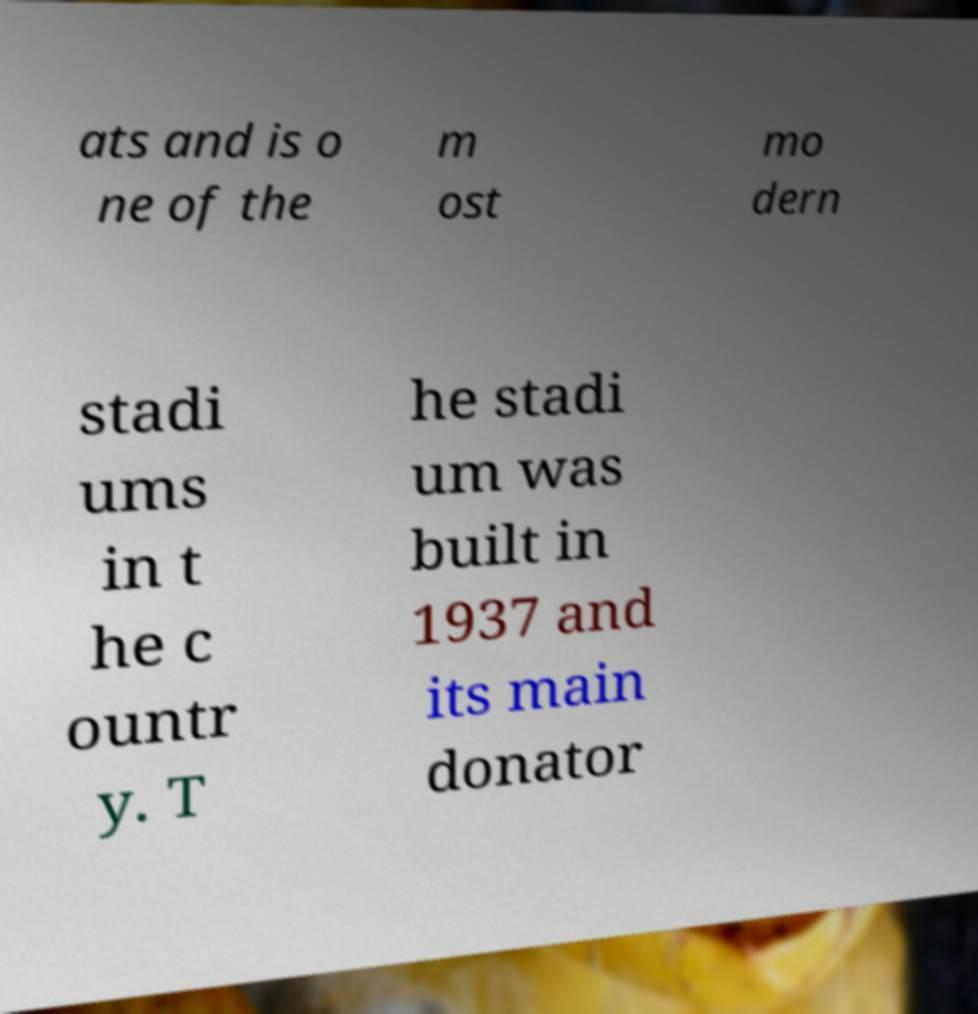What messages or text are displayed in this image? I need them in a readable, typed format. ats and is o ne of the m ost mo dern stadi ums in t he c ountr y. T he stadi um was built in 1937 and its main donator 